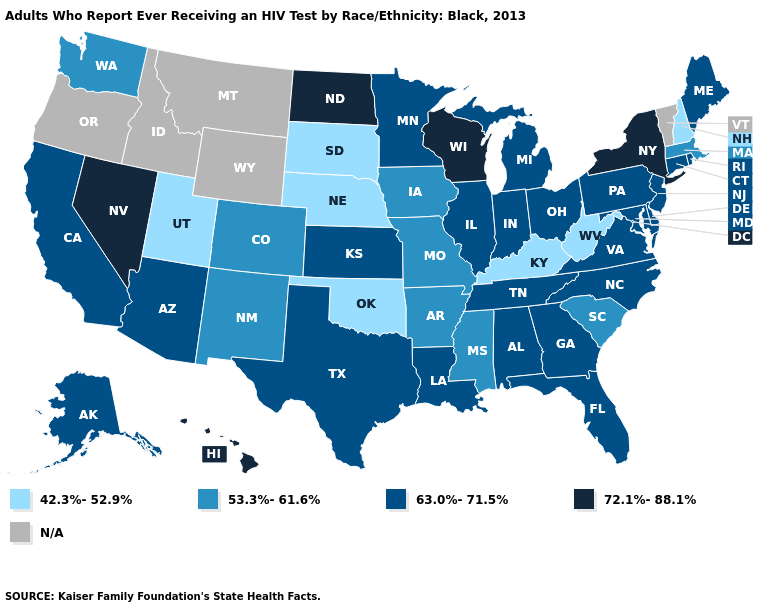Among the states that border North Carolina , does South Carolina have the lowest value?
Quick response, please. Yes. Which states hav the highest value in the Northeast?
Keep it brief. New York. Name the states that have a value in the range 53.3%-61.6%?
Be succinct. Arkansas, Colorado, Iowa, Massachusetts, Mississippi, Missouri, New Mexico, South Carolina, Washington. Among the states that border Minnesota , does North Dakota have the highest value?
Concise answer only. Yes. Name the states that have a value in the range 63.0%-71.5%?
Write a very short answer. Alabama, Alaska, Arizona, California, Connecticut, Delaware, Florida, Georgia, Illinois, Indiana, Kansas, Louisiana, Maine, Maryland, Michigan, Minnesota, New Jersey, North Carolina, Ohio, Pennsylvania, Rhode Island, Tennessee, Texas, Virginia. Name the states that have a value in the range 72.1%-88.1%?
Write a very short answer. Hawaii, Nevada, New York, North Dakota, Wisconsin. What is the lowest value in the South?
Be succinct. 42.3%-52.9%. Name the states that have a value in the range N/A?
Be succinct. Idaho, Montana, Oregon, Vermont, Wyoming. Name the states that have a value in the range N/A?
Concise answer only. Idaho, Montana, Oregon, Vermont, Wyoming. What is the highest value in the USA?
Give a very brief answer. 72.1%-88.1%. What is the value of California?
Answer briefly. 63.0%-71.5%. What is the value of New York?
Short answer required. 72.1%-88.1%. What is the highest value in the USA?
Quick response, please. 72.1%-88.1%. Name the states that have a value in the range 72.1%-88.1%?
Be succinct. Hawaii, Nevada, New York, North Dakota, Wisconsin. 